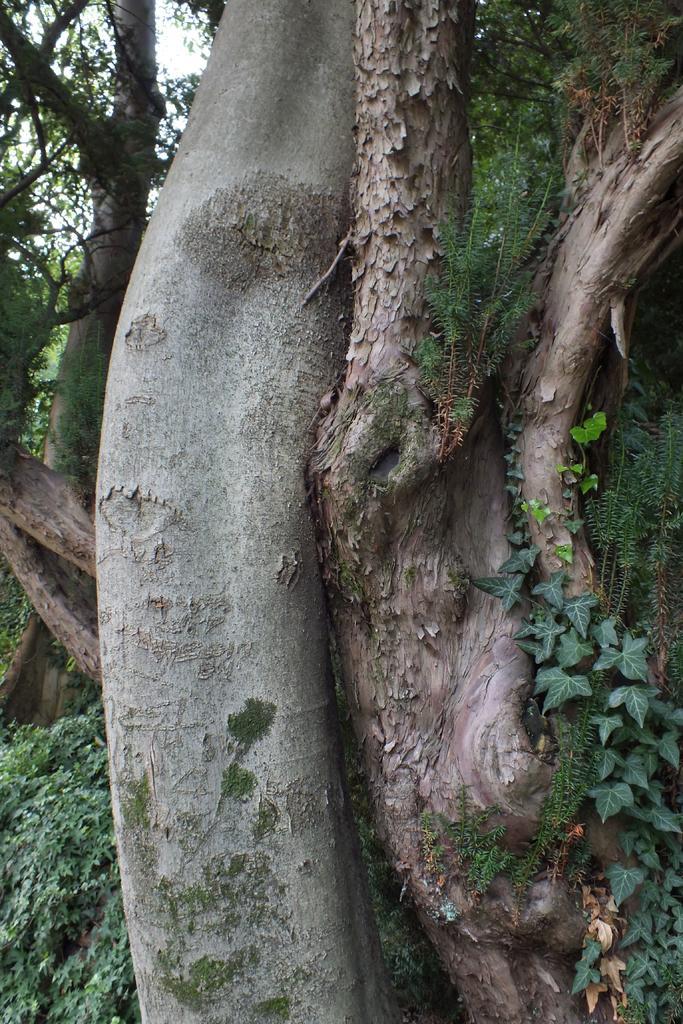Can you describe this image briefly? In this image we can see the bark of a tree, some plants, a tree and the sky which looks cloudy. 